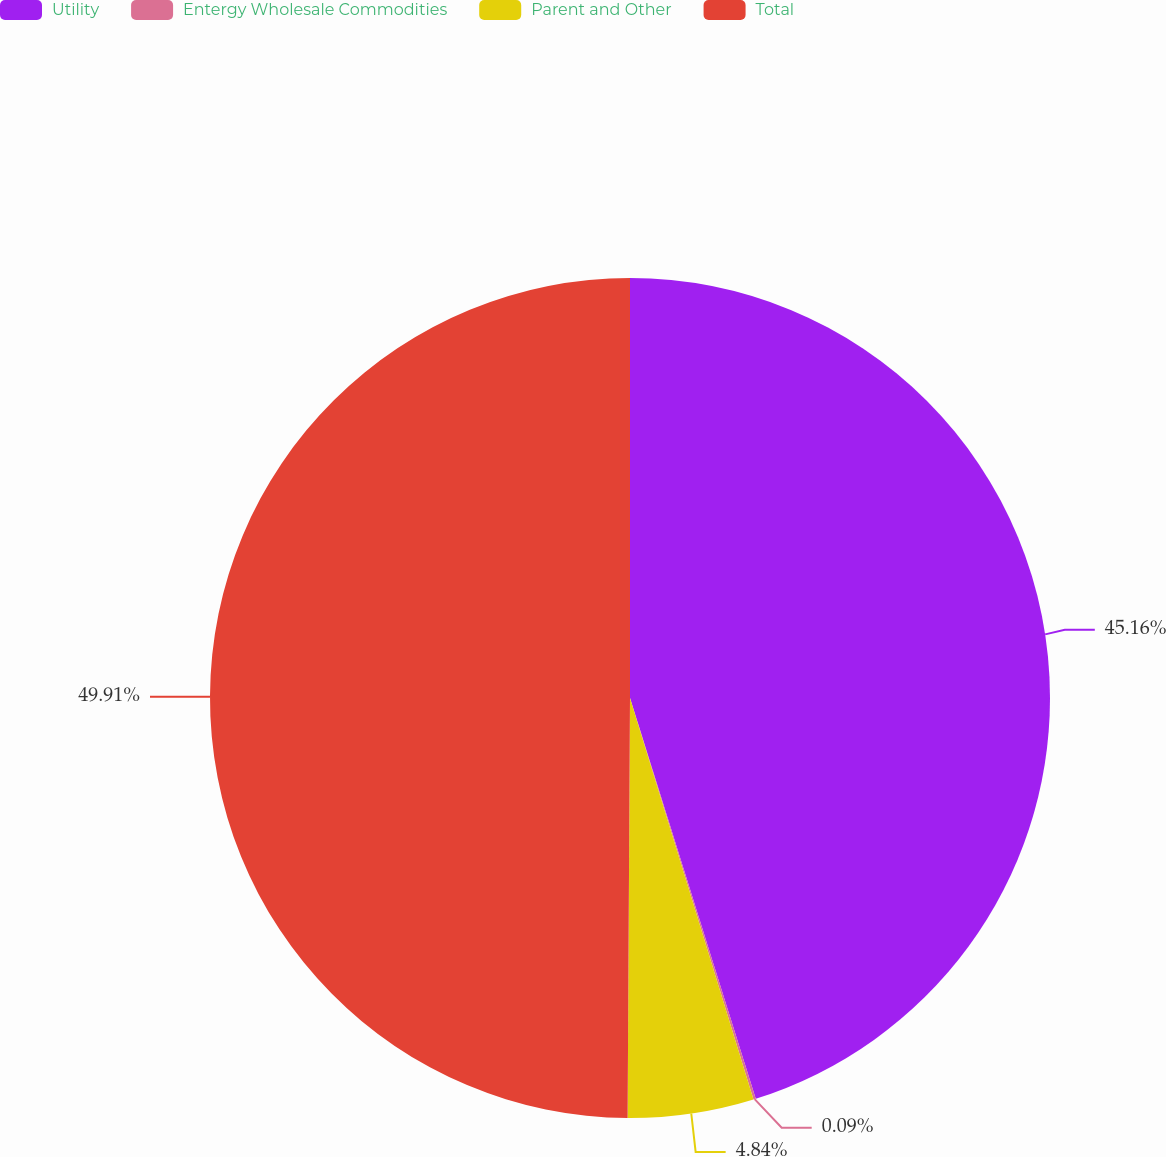Convert chart to OTSL. <chart><loc_0><loc_0><loc_500><loc_500><pie_chart><fcel>Utility<fcel>Entergy Wholesale Commodities<fcel>Parent and Other<fcel>Total<nl><fcel>45.16%<fcel>0.09%<fcel>4.84%<fcel>49.91%<nl></chart> 